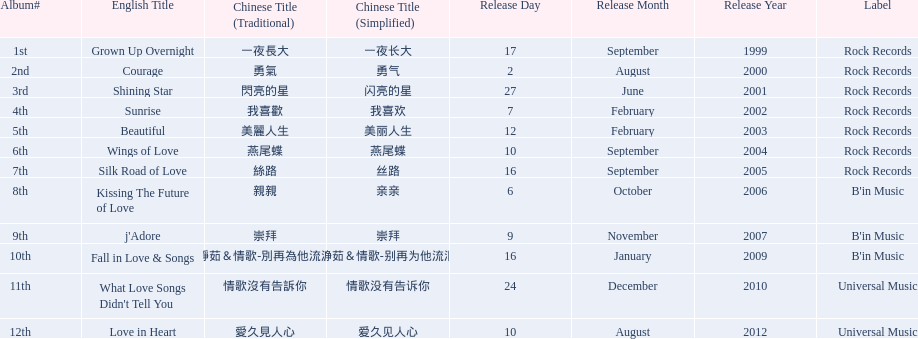Which songs did b'in music produce? Kissing The Future of Love, j'Adore, Fall in Love & Songs. Which one was released in an even numbered year? Kissing The Future of Love. 